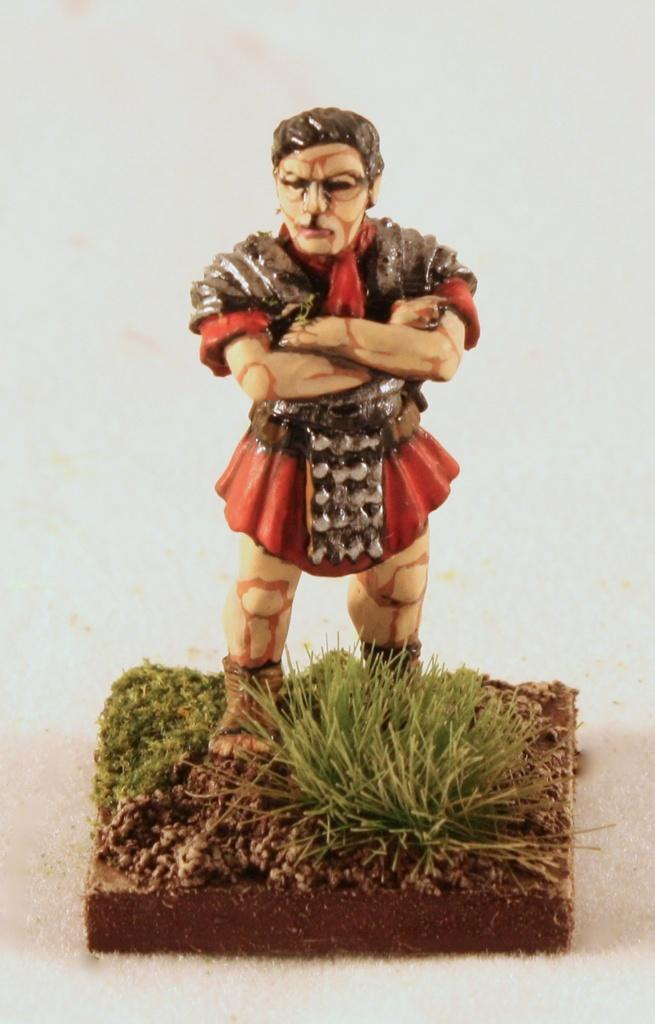What object can be seen in the picture? There is a toy in the picture. Where is the toy located? The toy is on a grass surface. Can you describe the surroundings of the grass surface? The grass surface is situated between soil. What type of gun is placed on the cushion in the image? There is no gun or cushion present in the image; it features a toy on a grass surface situated between soil. 